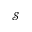<formula> <loc_0><loc_0><loc_500><loc_500>\mathcal { S }</formula> 